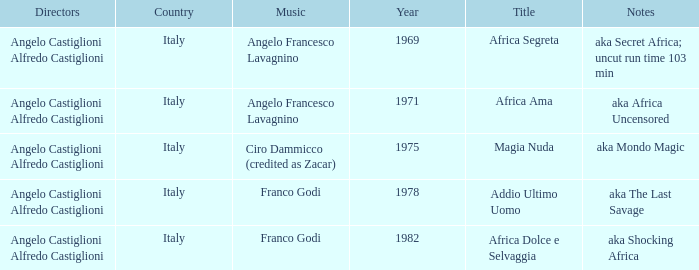How many years have a Title of Magia Nuda? 1.0. 